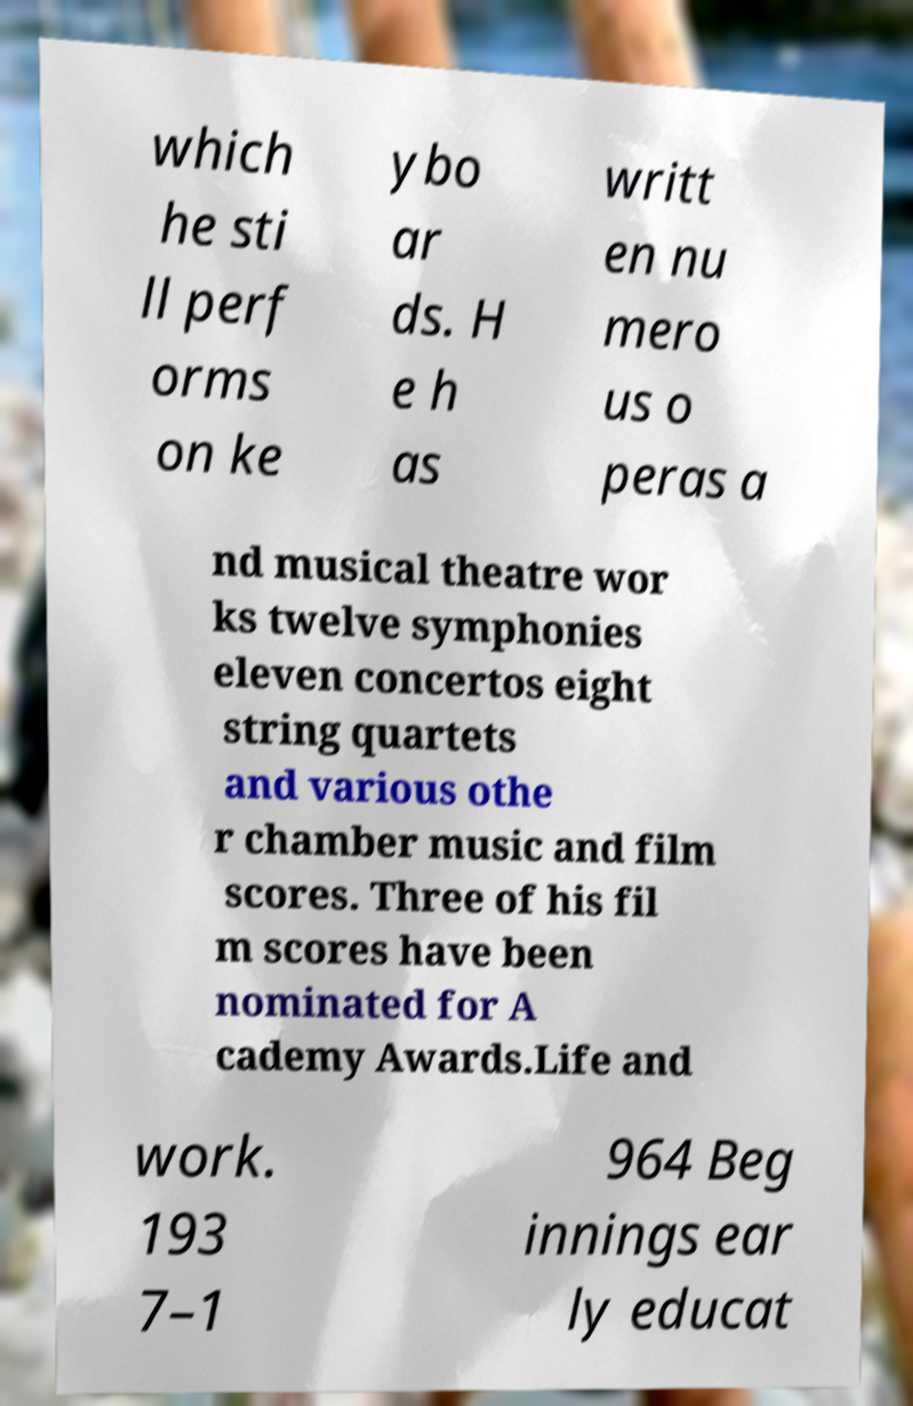Can you accurately transcribe the text from the provided image for me? which he sti ll perf orms on ke ybo ar ds. H e h as writt en nu mero us o peras a nd musical theatre wor ks twelve symphonies eleven concertos eight string quartets and various othe r chamber music and film scores. Three of his fil m scores have been nominated for A cademy Awards.Life and work. 193 7–1 964 Beg innings ear ly educat 